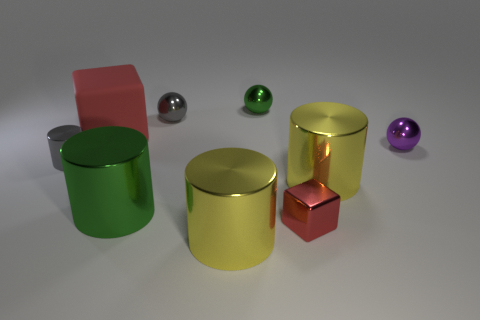Subtract all big metal cylinders. How many cylinders are left? 1 Subtract all gray balls. How many balls are left? 2 Subtract all spheres. How many objects are left? 6 Add 6 small purple things. How many small purple things are left? 7 Add 2 small yellow rubber cubes. How many small yellow rubber cubes exist? 2 Subtract 0 blue cubes. How many objects are left? 9 Subtract 2 blocks. How many blocks are left? 0 Subtract all cyan spheres. Subtract all brown cubes. How many spheres are left? 3 Subtract all blue blocks. How many yellow balls are left? 0 Subtract all green metallic cylinders. Subtract all small gray cylinders. How many objects are left? 7 